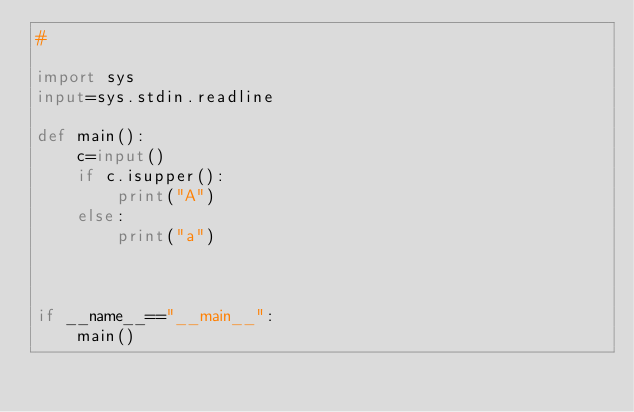Convert code to text. <code><loc_0><loc_0><loc_500><loc_500><_Python_>#

import sys
input=sys.stdin.readline

def main():
    c=input()
    if c.isupper():
        print("A")
    else:
        print("a")
    
    
    
if __name__=="__main__":
    main()
</code> 